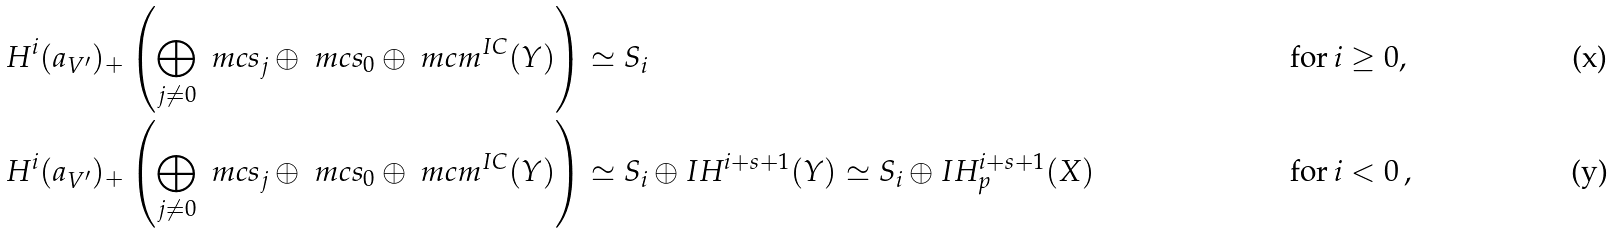<formula> <loc_0><loc_0><loc_500><loc_500>H ^ { i } ( a _ { V ^ { \prime } } ) _ { + } \left ( \bigoplus _ { j \neq 0 } \ m c s _ { j } \oplus \ m c s _ { 0 } \oplus \ m c m ^ { I C } ( Y ) \right ) & \simeq S _ { i } & & \text {for} \, i \geq 0 , \\ H ^ { i } ( a _ { V ^ { \prime } } ) _ { + } \left ( \bigoplus _ { j \neq 0 } \ m c s _ { j } \oplus \ m c s _ { 0 } \oplus \ m c m ^ { I C } ( Y ) \right ) & \simeq S _ { i } \oplus I H ^ { i + s + 1 } ( Y ) \simeq S _ { i } \oplus I H ^ { i + s + 1 } _ { p } ( X ) & & \text {for} \, i < 0 \, ,</formula> 